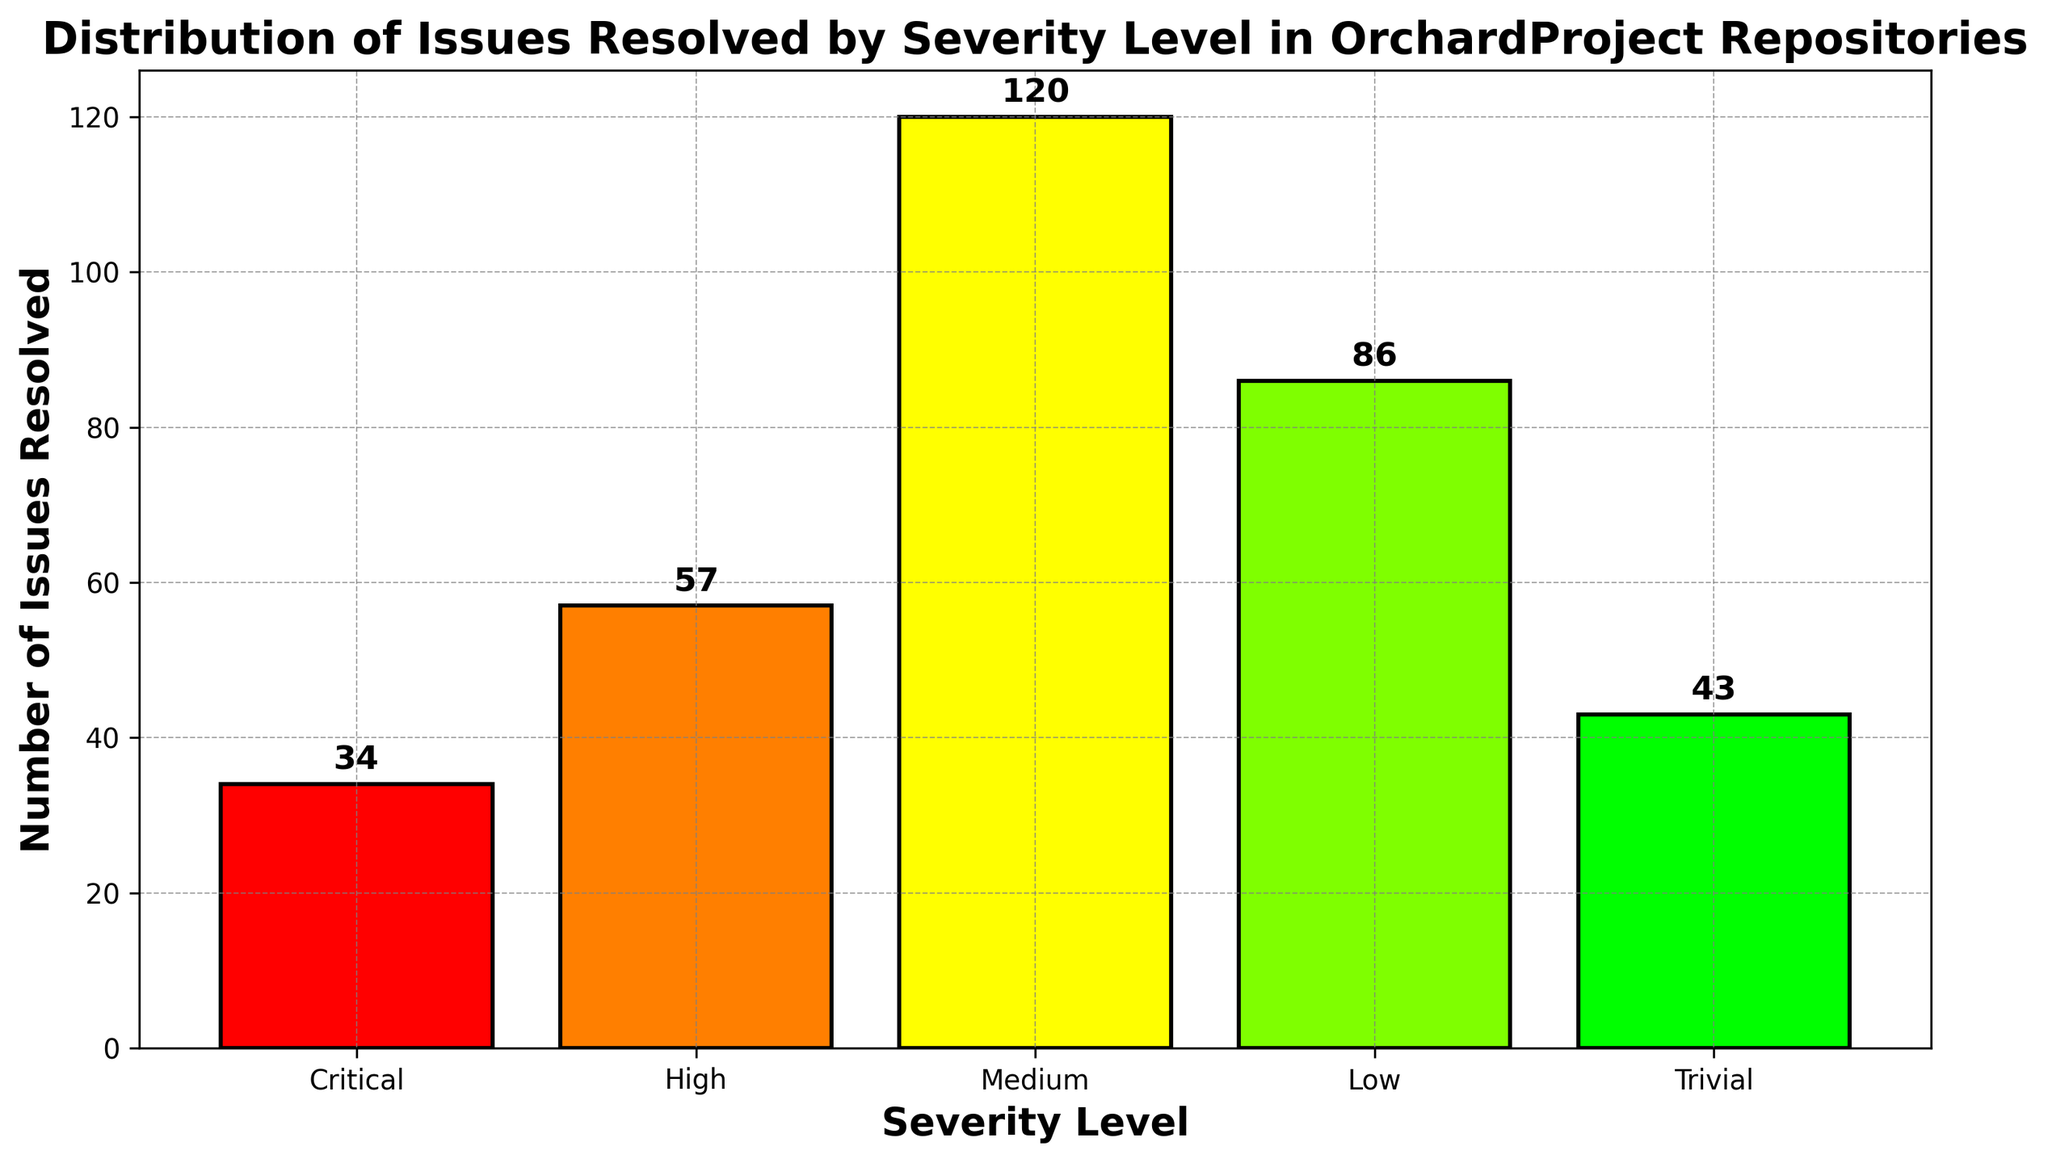Which severity level has the highest number of issues resolved? The bar representing the 'Medium' severity level is the tallest, indicating it has the highest number of issues resolved.
Answer: Medium What is the total number of issues resolved across all severity levels? Add the values from all bars: 34 (Critical) + 57 (High) + 120 (Medium) + 86 (Low) + 43 (Trivial) = 340.
Answer: 340 How many more issues were resolved at the Medium level compared to the Critical level? Subtract the number of issues resolved at the Critical level from the Medium level: 120 (Medium) - 34 (Critical) = 86.
Answer: 86 Which two severity levels combined have resolved exactly 100 issues? 'Critical' and 'Trivial' combined: 34 (Critical) + 43 (Trivial) = 77; 'Trivial' and 'Low' combined: 43 (Trivial) + 86 (Low) = 129; 'Critical' and 'Low' combined: 34 (Critical) + 86 (Low) = 120; No pair equals 100. Therefore, 'Critical' and 'High': 34 (Critical) + 57 (High) = 91. Therefore, no such combination exists within the provided data.
Answer: None What is the difference between the highest and the lowest number of issues resolved among the severity levels? Subtract the number of issues resolved in the 'Trivial' (the lowest) from the 'Medium' (the highest): 120 (Medium) - 34 (Critical) = 86.
Answer: 86 List all severity levels where more than 50 issues have been resolved. The bars for 'High', 'Medium', and 'Low' are higher than the 50-mark on the y-axis.
Answer: High, Medium, Low What's the average number of issues resolved per severity level? Sum the number of issues resolved for all levels and divide by the number of levels: (34 + 57 + 120 + 86 + 43) / 5 = 340 / 5 = 68.
Answer: 68 If issues resolved at the 'Critical' level doubled, would it surpass 'Low'? Doubling 'Critical' issues: 34 * 2 = 68; compare it to 'Low': 86. 68 is not greater than 86.
Answer: No What proportion of the total number of issues resolved were 'Trivial' issues? Divide the number of 'Trivial' issues by the total number of issues: 43 / 340 ≈ 0.126; approximately 12.6%.
Answer: ~12.6% Which bar is colored green, and what does it represent? The green bars indicate the 'Low' severity level on the x-axis and it represents 86 issues resolved.
Answer: Low 